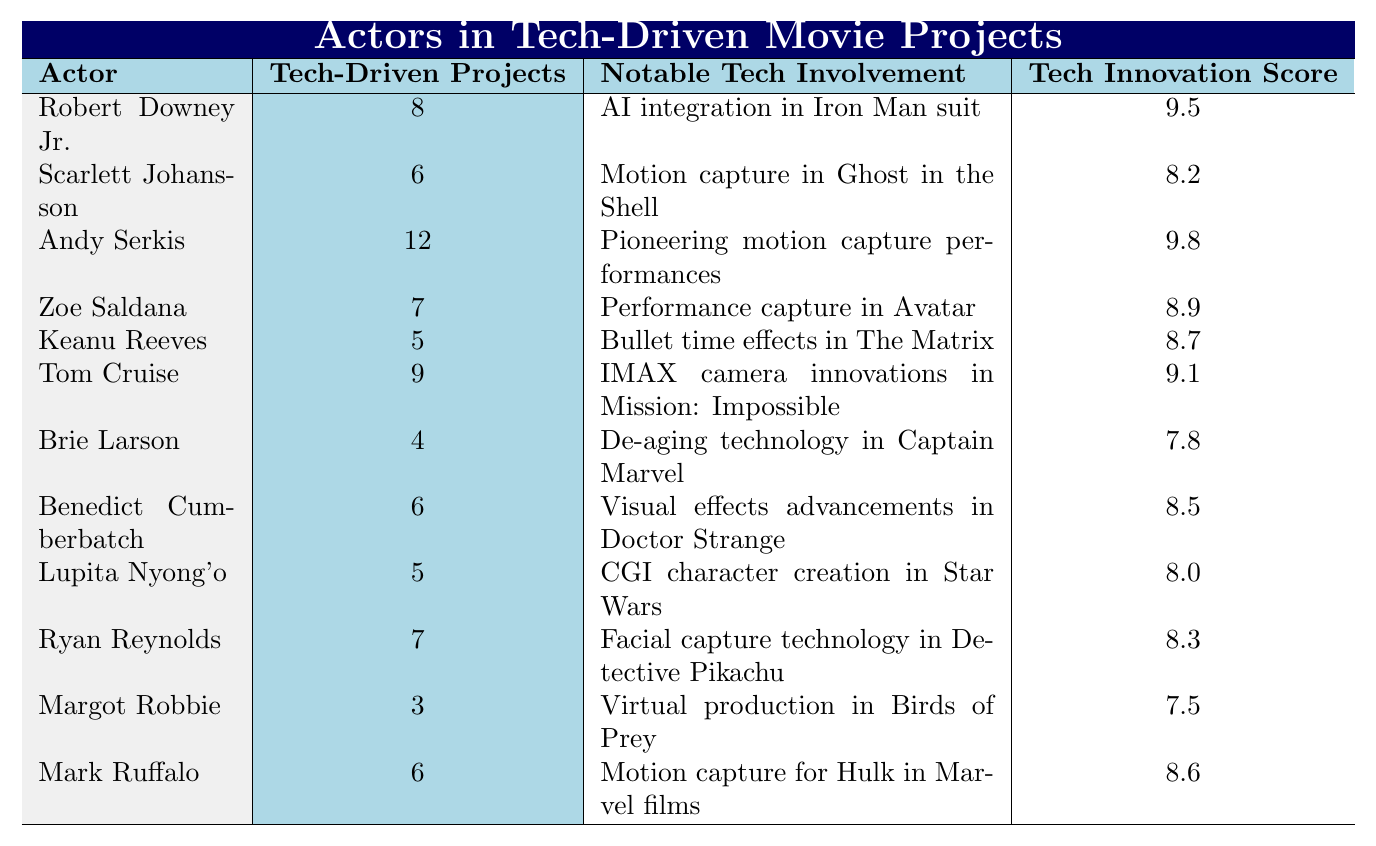What actor has the highest Tech Innovation Score? The table lists the Tech Innovation Scores for each actor, and Andy Serkis has the highest score at 9.8.
Answer: Andy Serkis How many tech-driven projects has Robert Downey Jr. been involved in? The table shows that Robert Downey Jr. has been involved in 8 tech-driven projects.
Answer: 8 Which actor is known for pioneering motion capture performances? Referring to the notable tech involvement column, Andy Serkis is recognized for pioneering motion capture performances in the table.
Answer: Andy Serkis What is the average Tech Innovation Score of the actors listed? To find the average, sum all Tech Innovation Scores (9.5 + 8.2 + 9.8 + 8.9 + 8.7 + 9.1 + 7.8 + 8.5 + 8.0 + 8.3 + 7.5 + 8.6 = 105.4), then divide by the number of actors (12): 105.4 / 12 ≈ 8.78.
Answer: Approximately 8.78 Does Zoe Saldana’s Tech Innovation Score exceed 8.5? Zoe Saldana has a Tech Innovation Score of 8.9, which is greater than 8.5 according to the table.
Answer: Yes Which actor has the lowest number of tech-driven projects? The table indicates that Margot Robbie has the lowest number of tech-driven projects at just 3.
Answer: Margot Robbie How does Keanu Reeves' Tech Innovation Score compare to Tom Cruise's? Keanu Reeves has a Tech Innovation Score of 8.7, while Tom Cruise's score is 9.1. Since 8.7 is less than 9.1, Keanu's score is lower.
Answer: Lower What notable technology is associated with Ryan Reynolds? The table specifies that Ryan Reynolds is known for facial capture technology in Detective Pikachu.
Answer: Facial capture technology in Detective Pikachu Who has more Tech-Driven Projects, Scarlett Johansson or Benedict Cumberbatch? Scarlett Johansson has 6 tech-driven projects, while Benedict Cumberbatch also has 6. Since the counts are equal, neither has more.
Answer: Neither If you combine the Tech-Driven Projects of both Andy Serkis and Robert Downey Jr., what is the total? Andy Serkis has 12 tech-driven projects and Robert Downey Jr. has 8. Adding them gives 12 + 8 = 20, which is the total.
Answer: 20 